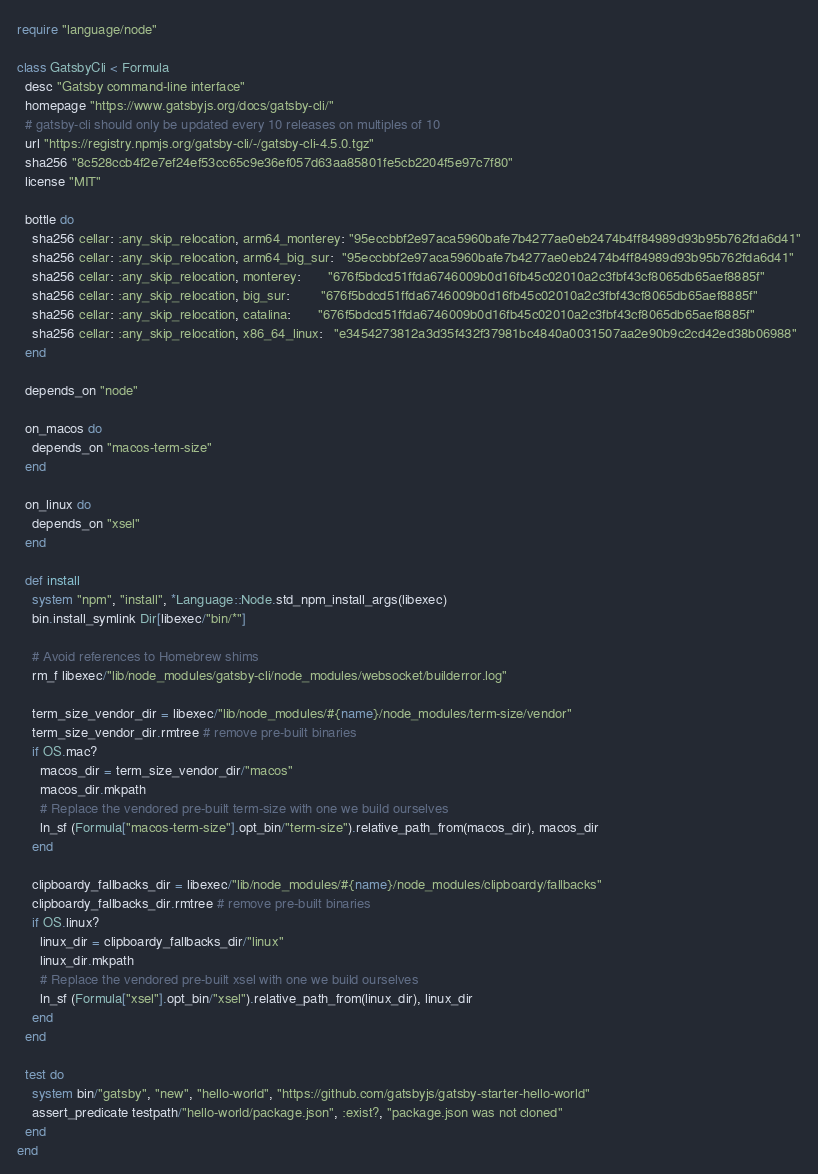Convert code to text. <code><loc_0><loc_0><loc_500><loc_500><_Ruby_>require "language/node"

class GatsbyCli < Formula
  desc "Gatsby command-line interface"
  homepage "https://www.gatsbyjs.org/docs/gatsby-cli/"
  # gatsby-cli should only be updated every 10 releases on multiples of 10
  url "https://registry.npmjs.org/gatsby-cli/-/gatsby-cli-4.5.0.tgz"
  sha256 "8c528ccb4f2e7ef24ef53cc65c9e36ef057d63aa85801fe5cb2204f5e97c7f80"
  license "MIT"

  bottle do
    sha256 cellar: :any_skip_relocation, arm64_monterey: "95eccbbf2e97aca5960bafe7b4277ae0eb2474b4ff84989d93b95b762fda6d41"
    sha256 cellar: :any_skip_relocation, arm64_big_sur:  "95eccbbf2e97aca5960bafe7b4277ae0eb2474b4ff84989d93b95b762fda6d41"
    sha256 cellar: :any_skip_relocation, monterey:       "676f5bdcd51ffda6746009b0d16fb45c02010a2c3fbf43cf8065db65aef8885f"
    sha256 cellar: :any_skip_relocation, big_sur:        "676f5bdcd51ffda6746009b0d16fb45c02010a2c3fbf43cf8065db65aef8885f"
    sha256 cellar: :any_skip_relocation, catalina:       "676f5bdcd51ffda6746009b0d16fb45c02010a2c3fbf43cf8065db65aef8885f"
    sha256 cellar: :any_skip_relocation, x86_64_linux:   "e3454273812a3d35f432f37981bc4840a0031507aa2e90b9c2cd42ed38b06988"
  end

  depends_on "node"

  on_macos do
    depends_on "macos-term-size"
  end

  on_linux do
    depends_on "xsel"
  end

  def install
    system "npm", "install", *Language::Node.std_npm_install_args(libexec)
    bin.install_symlink Dir[libexec/"bin/*"]

    # Avoid references to Homebrew shims
    rm_f libexec/"lib/node_modules/gatsby-cli/node_modules/websocket/builderror.log"

    term_size_vendor_dir = libexec/"lib/node_modules/#{name}/node_modules/term-size/vendor"
    term_size_vendor_dir.rmtree # remove pre-built binaries
    if OS.mac?
      macos_dir = term_size_vendor_dir/"macos"
      macos_dir.mkpath
      # Replace the vendored pre-built term-size with one we build ourselves
      ln_sf (Formula["macos-term-size"].opt_bin/"term-size").relative_path_from(macos_dir), macos_dir
    end

    clipboardy_fallbacks_dir = libexec/"lib/node_modules/#{name}/node_modules/clipboardy/fallbacks"
    clipboardy_fallbacks_dir.rmtree # remove pre-built binaries
    if OS.linux?
      linux_dir = clipboardy_fallbacks_dir/"linux"
      linux_dir.mkpath
      # Replace the vendored pre-built xsel with one we build ourselves
      ln_sf (Formula["xsel"].opt_bin/"xsel").relative_path_from(linux_dir), linux_dir
    end
  end

  test do
    system bin/"gatsby", "new", "hello-world", "https://github.com/gatsbyjs/gatsby-starter-hello-world"
    assert_predicate testpath/"hello-world/package.json", :exist?, "package.json was not cloned"
  end
end
</code> 